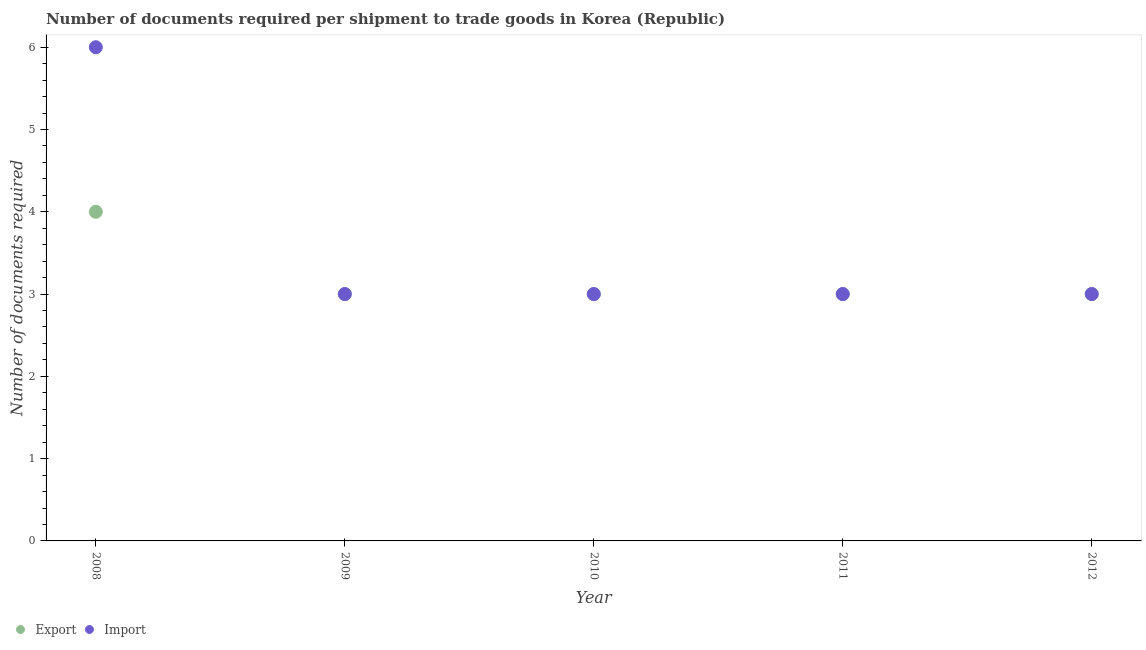Is the number of dotlines equal to the number of legend labels?
Ensure brevity in your answer.  Yes. What is the number of documents required to export goods in 2010?
Offer a terse response. 3. Across all years, what is the minimum number of documents required to import goods?
Your response must be concise. 3. In which year was the number of documents required to export goods maximum?
Provide a succinct answer. 2008. In which year was the number of documents required to import goods minimum?
Offer a very short reply. 2009. What is the total number of documents required to import goods in the graph?
Make the answer very short. 18. What is the difference between the number of documents required to export goods in 2011 and the number of documents required to import goods in 2008?
Your response must be concise. -3. In the year 2012, what is the difference between the number of documents required to import goods and number of documents required to export goods?
Offer a terse response. 0. In how many years, is the number of documents required to export goods greater than 1.2?
Your answer should be very brief. 5. Is the number of documents required to export goods in 2008 less than that in 2012?
Offer a terse response. No. What is the difference between the highest and the lowest number of documents required to export goods?
Provide a short and direct response. 1. In how many years, is the number of documents required to export goods greater than the average number of documents required to export goods taken over all years?
Offer a very short reply. 1. Is the sum of the number of documents required to export goods in 2010 and 2011 greater than the maximum number of documents required to import goods across all years?
Keep it short and to the point. No. Is the number of documents required to import goods strictly greater than the number of documents required to export goods over the years?
Provide a succinct answer. No. How many dotlines are there?
Provide a short and direct response. 2. How many years are there in the graph?
Ensure brevity in your answer.  5. Are the values on the major ticks of Y-axis written in scientific E-notation?
Provide a succinct answer. No. Does the graph contain any zero values?
Provide a succinct answer. No. Does the graph contain grids?
Provide a short and direct response. No. What is the title of the graph?
Your answer should be very brief. Number of documents required per shipment to trade goods in Korea (Republic). Does "Forest land" appear as one of the legend labels in the graph?
Ensure brevity in your answer.  No. What is the label or title of the Y-axis?
Provide a succinct answer. Number of documents required. What is the Number of documents required in Import in 2008?
Provide a succinct answer. 6. What is the Number of documents required in Import in 2009?
Make the answer very short. 3. What is the Number of documents required in Export in 2010?
Offer a terse response. 3. What is the Number of documents required in Import in 2010?
Your answer should be very brief. 3. What is the Number of documents required in Export in 2012?
Your response must be concise. 3. Across all years, what is the maximum Number of documents required in Export?
Your answer should be compact. 4. Across all years, what is the minimum Number of documents required in Import?
Give a very brief answer. 3. What is the total Number of documents required of Export in the graph?
Give a very brief answer. 16. What is the total Number of documents required in Import in the graph?
Provide a short and direct response. 18. What is the difference between the Number of documents required in Export in 2008 and that in 2009?
Give a very brief answer. 1. What is the difference between the Number of documents required of Export in 2008 and that in 2010?
Offer a terse response. 1. What is the difference between the Number of documents required in Import in 2008 and that in 2010?
Give a very brief answer. 3. What is the difference between the Number of documents required in Export in 2008 and that in 2011?
Make the answer very short. 1. What is the difference between the Number of documents required in Import in 2008 and that in 2012?
Give a very brief answer. 3. What is the difference between the Number of documents required in Import in 2009 and that in 2012?
Provide a short and direct response. 0. What is the difference between the Number of documents required of Import in 2010 and that in 2011?
Ensure brevity in your answer.  0. What is the difference between the Number of documents required in Import in 2010 and that in 2012?
Your answer should be very brief. 0. What is the difference between the Number of documents required of Export in 2011 and that in 2012?
Your response must be concise. 0. What is the difference between the Number of documents required of Export in 2008 and the Number of documents required of Import in 2009?
Your response must be concise. 1. What is the difference between the Number of documents required of Export in 2008 and the Number of documents required of Import in 2010?
Your response must be concise. 1. What is the difference between the Number of documents required of Export in 2008 and the Number of documents required of Import in 2012?
Keep it short and to the point. 1. What is the difference between the Number of documents required in Export in 2009 and the Number of documents required in Import in 2011?
Keep it short and to the point. 0. What is the difference between the Number of documents required in Export in 2009 and the Number of documents required in Import in 2012?
Your answer should be very brief. 0. What is the difference between the Number of documents required in Export in 2010 and the Number of documents required in Import in 2011?
Ensure brevity in your answer.  0. What is the difference between the Number of documents required in Export in 2011 and the Number of documents required in Import in 2012?
Provide a short and direct response. 0. What is the average Number of documents required in Export per year?
Make the answer very short. 3.2. In the year 2010, what is the difference between the Number of documents required in Export and Number of documents required in Import?
Your answer should be compact. 0. What is the ratio of the Number of documents required in Export in 2008 to that in 2009?
Provide a short and direct response. 1.33. What is the ratio of the Number of documents required in Export in 2008 to that in 2010?
Your answer should be compact. 1.33. What is the ratio of the Number of documents required of Export in 2009 to that in 2010?
Your answer should be compact. 1. What is the ratio of the Number of documents required of Import in 2009 to that in 2011?
Your answer should be compact. 1. What is the ratio of the Number of documents required of Export in 2009 to that in 2012?
Ensure brevity in your answer.  1. What is the ratio of the Number of documents required of Import in 2009 to that in 2012?
Your answer should be compact. 1. What is the ratio of the Number of documents required of Export in 2010 to that in 2011?
Your answer should be compact. 1. What is the ratio of the Number of documents required in Import in 2010 to that in 2011?
Make the answer very short. 1. What is the ratio of the Number of documents required in Export in 2010 to that in 2012?
Make the answer very short. 1. What is the ratio of the Number of documents required in Export in 2011 to that in 2012?
Keep it short and to the point. 1. What is the ratio of the Number of documents required of Import in 2011 to that in 2012?
Make the answer very short. 1. What is the difference between the highest and the second highest Number of documents required in Export?
Your answer should be very brief. 1. 